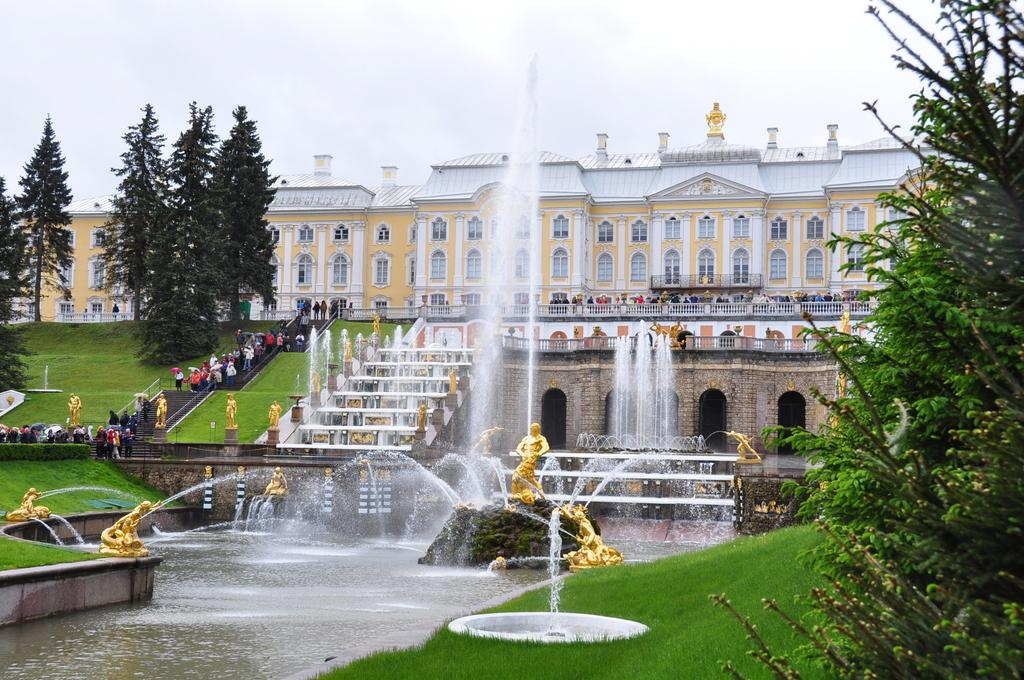What is the main feature in the image? There is a water fountain in the image. What is flowing from the water fountain? Water is visible in the image. What type of natural environment is present in the image? There is grass and trees in the image. Are there any people in the image? Yes, there are persons in the image. What architectural features can be seen in the image? There are stairs, a building, and a bridge in the image. What is visible in the sky? The sky is visible in the image. What type of noise can be heard coming from the icicle in the image? There is no icicle present in the image, so it is not possible to determine what noise might be heard. What is the plot of the story unfolding in the image? The image does not depict a story or plot; it is a scene featuring a water fountain, people, and various architectural elements. 